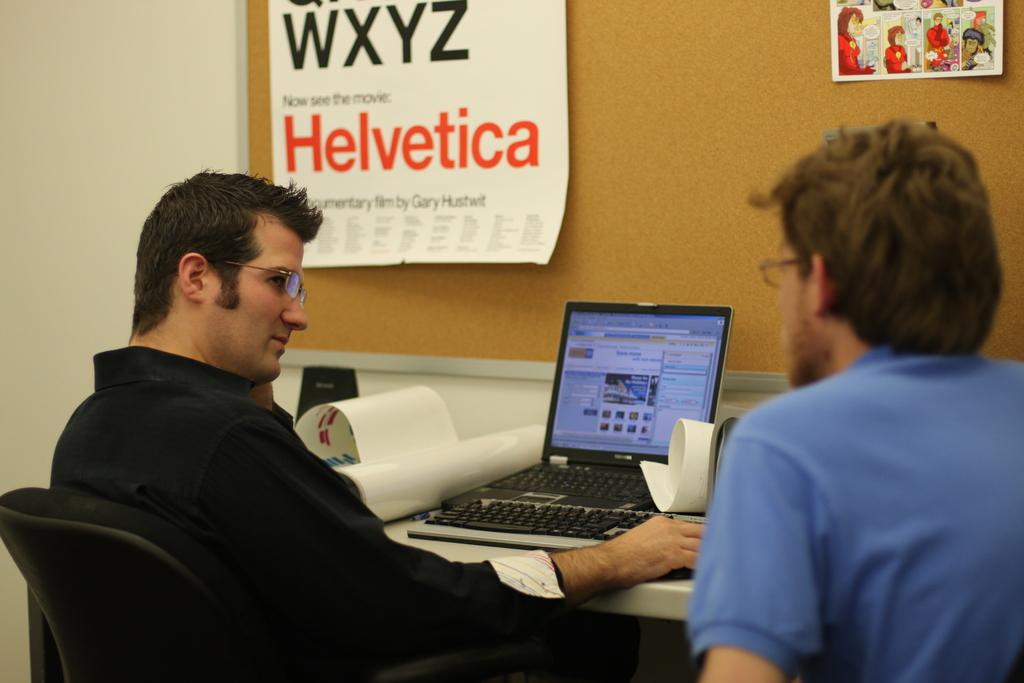What is the word in red?
Keep it short and to the point. Helvetica. What letters are in large black print on the left?
Provide a short and direct response. Wxyz. 